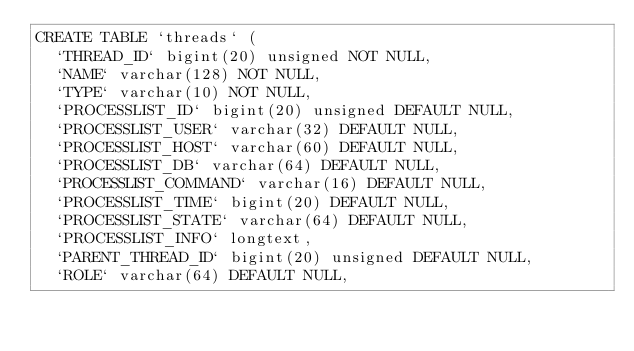<code> <loc_0><loc_0><loc_500><loc_500><_SQL_>CREATE TABLE `threads` (
  `THREAD_ID` bigint(20) unsigned NOT NULL,
  `NAME` varchar(128) NOT NULL,
  `TYPE` varchar(10) NOT NULL,
  `PROCESSLIST_ID` bigint(20) unsigned DEFAULT NULL,
  `PROCESSLIST_USER` varchar(32) DEFAULT NULL,
  `PROCESSLIST_HOST` varchar(60) DEFAULT NULL,
  `PROCESSLIST_DB` varchar(64) DEFAULT NULL,
  `PROCESSLIST_COMMAND` varchar(16) DEFAULT NULL,
  `PROCESSLIST_TIME` bigint(20) DEFAULT NULL,
  `PROCESSLIST_STATE` varchar(64) DEFAULT NULL,
  `PROCESSLIST_INFO` longtext,
  `PARENT_THREAD_ID` bigint(20) unsigned DEFAULT NULL,
  `ROLE` varchar(64) DEFAULT NULL,</code> 